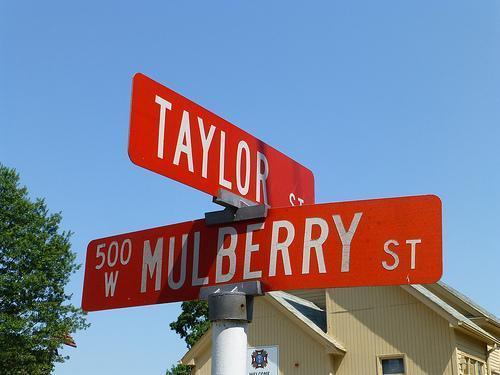How many signs?
Give a very brief answer. 2. 